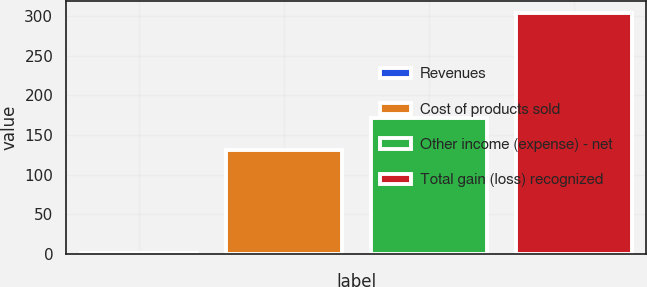<chart> <loc_0><loc_0><loc_500><loc_500><bar_chart><fcel>Revenues<fcel>Cost of products sold<fcel>Other income (expense) - net<fcel>Total gain (loss) recognized<nl><fcel>1<fcel>131<fcel>171<fcel>304<nl></chart> 